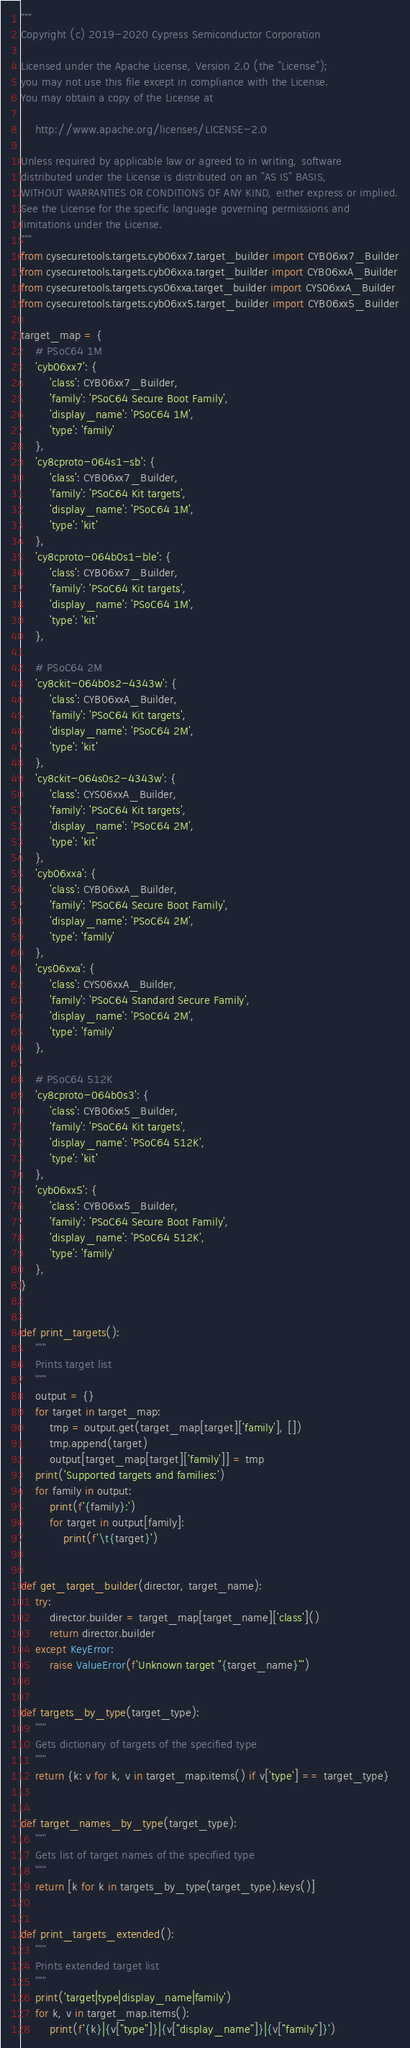<code> <loc_0><loc_0><loc_500><loc_500><_Python_>"""
Copyright (c) 2019-2020 Cypress Semiconductor Corporation

Licensed under the Apache License, Version 2.0 (the "License");
you may not use this file except in compliance with the License.
You may obtain a copy of the License at

    http://www.apache.org/licenses/LICENSE-2.0

Unless required by applicable law or agreed to in writing, software
distributed under the License is distributed on an "AS IS" BASIS,
WITHOUT WARRANTIES OR CONDITIONS OF ANY KIND, either express or implied.
See the License for the specific language governing permissions and
limitations under the License.
"""
from cysecuretools.targets.cyb06xx7.target_builder import CYB06xx7_Builder
from cysecuretools.targets.cyb06xxa.target_builder import CYB06xxA_Builder
from cysecuretools.targets.cys06xxa.target_builder import CYS06xxA_Builder
from cysecuretools.targets.cyb06xx5.target_builder import CYB06xx5_Builder

target_map = {
    # PSoC64 1M
    'cyb06xx7': {
        'class': CYB06xx7_Builder,
        'family': 'PSoC64 Secure Boot Family',
        'display_name': 'PSoC64 1M',
        'type': 'family'
    },
    'cy8cproto-064s1-sb': {
        'class': CYB06xx7_Builder,
        'family': 'PSoC64 Kit targets',
        'display_name': 'PSoC64 1M',
        'type': 'kit'
    },
    'cy8cproto-064b0s1-ble': {
        'class': CYB06xx7_Builder,
        'family': 'PSoC64 Kit targets',
        'display_name': 'PSoC64 1M',
        'type': 'kit'
    },

    # PSoC64 2M
    'cy8ckit-064b0s2-4343w': {
        'class': CYB06xxA_Builder,
        'family': 'PSoC64 Kit targets',
        'display_name': 'PSoC64 2M',
        'type': 'kit'
    },
    'cy8ckit-064s0s2-4343w': {
        'class': CYS06xxA_Builder,
        'family': 'PSoC64 Kit targets',
        'display_name': 'PSoC64 2M',
        'type': 'kit'
    },
    'cyb06xxa': {
        'class': CYB06xxA_Builder,
        'family': 'PSoC64 Secure Boot Family',
        'display_name': 'PSoC64 2M',
        'type': 'family'
    },
    'cys06xxa': {
        'class': CYS06xxA_Builder,
        'family': 'PSoC64 Standard Secure Family',
        'display_name': 'PSoC64 2M',
        'type': 'family'
    },

    # PSoC64 512K
    'cy8cproto-064b0s3': {
        'class': CYB06xx5_Builder,
        'family': 'PSoC64 Kit targets',
        'display_name': 'PSoC64 512K',
        'type': 'kit'
    },
    'cyb06xx5': {
        'class': CYB06xx5_Builder,
        'family': 'PSoC64 Secure Boot Family',
        'display_name': 'PSoC64 512K',
        'type': 'family'
    },
}


def print_targets():
    """
    Prints target list
    """
    output = {}
    for target in target_map:
        tmp = output.get(target_map[target]['family'], [])
        tmp.append(target)
        output[target_map[target]['family']] = tmp
    print('Supported targets and families:')
    for family in output:
        print(f'{family}:')
        for target in output[family]:
            print(f'\t{target}')


def get_target_builder(director, target_name):
    try:
        director.builder = target_map[target_name]['class']()
        return director.builder
    except KeyError:
        raise ValueError(f'Unknown target "{target_name}"')


def targets_by_type(target_type):
    """
    Gets dictionary of targets of the specified type
    """
    return {k: v for k, v in target_map.items() if v['type'] == target_type}


def target_names_by_type(target_type):
    """
    Gets list of target names of the specified type
    """
    return [k for k in targets_by_type(target_type).keys()]


def print_targets_extended():
    """
    Prints extended target list
    """
    print('target|type|display_name|family')
    for k, v in target_map.items():
        print(f'{k}|{v["type"]}|{v["display_name"]}|{v["family"]}')
</code> 